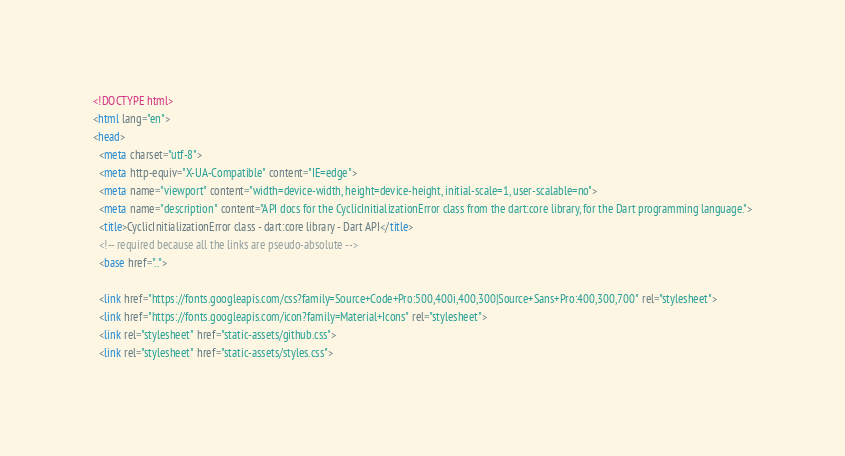<code> <loc_0><loc_0><loc_500><loc_500><_HTML_><!DOCTYPE html>
<html lang="en">
<head>
  <meta charset="utf-8">
  <meta http-equiv="X-UA-Compatible" content="IE=edge">
  <meta name="viewport" content="width=device-width, height=device-height, initial-scale=1, user-scalable=no">
  <meta name="description" content="API docs for the CyclicInitializationError class from the dart:core library, for the Dart programming language.">
  <title>CyclicInitializationError class - dart:core library - Dart API</title>
  <!-- required because all the links are pseudo-absolute -->
  <base href="..">

  <link href="https://fonts.googleapis.com/css?family=Source+Code+Pro:500,400i,400,300|Source+Sans+Pro:400,300,700" rel="stylesheet">
  <link href="https://fonts.googleapis.com/icon?family=Material+Icons" rel="stylesheet">
  <link rel="stylesheet" href="static-assets/github.css">
  <link rel="stylesheet" href="static-assets/styles.css"></code> 